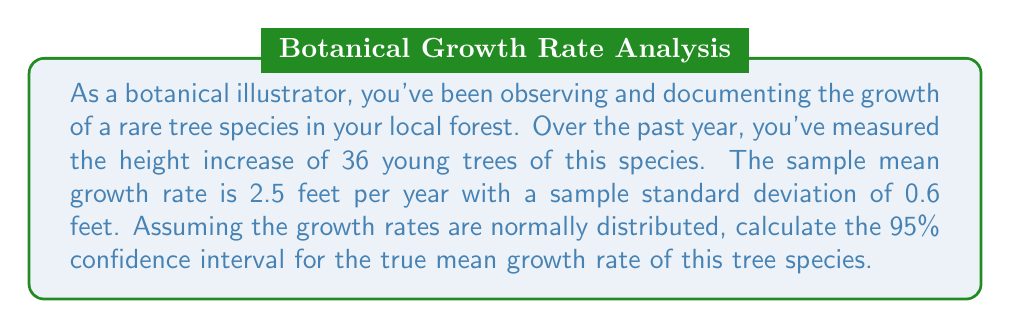Can you answer this question? Let's approach this step-by-step:

1) We're given:
   - Sample size: $n = 36$
   - Sample mean: $\bar{x} = 2.5$ feet/year
   - Sample standard deviation: $s = 0.6$ feet/year
   - Confidence level: 95%

2) For a 95% confidence interval, we use a $z$-score of 1.96 (assuming a large sample size).

3) The formula for the confidence interval is:

   $$\bar{x} \pm z \cdot \frac{s}{\sqrt{n}}$$

4) Let's calculate the standard error:
   $$\frac{s}{\sqrt{n}} = \frac{0.6}{\sqrt{36}} = \frac{0.6}{6} = 0.1$$

5) Now, let's calculate the margin of error:
   $$1.96 \cdot 0.1 = 0.196$$

6) Finally, we can calculate the confidence interval:
   Lower bound: $2.5 - 0.196 = 2.304$
   Upper bound: $2.5 + 0.196 = 2.696$

7) Rounding to two decimal places:
   The 95% confidence interval is (2.30, 2.70) feet per year.

This means we can be 95% confident that the true mean growth rate of this tree species falls between 2.30 and 2.70 feet per year.
Answer: (2.30, 2.70) feet/year 